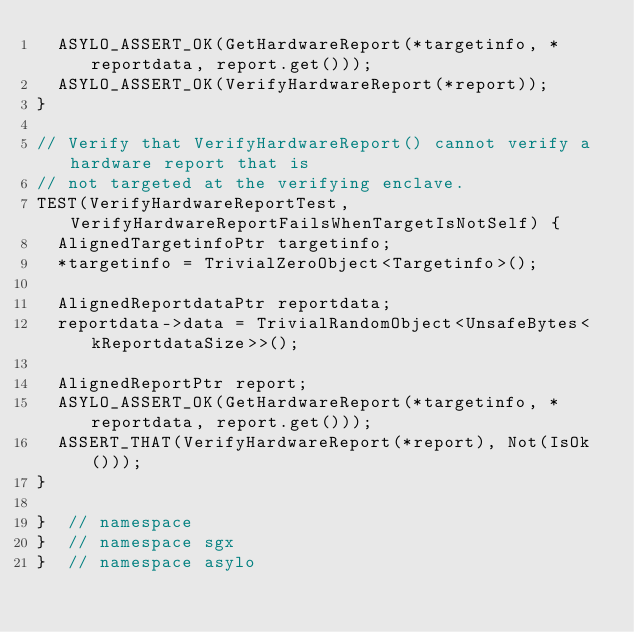Convert code to text. <code><loc_0><loc_0><loc_500><loc_500><_C++_>  ASYLO_ASSERT_OK(GetHardwareReport(*targetinfo, *reportdata, report.get()));
  ASYLO_ASSERT_OK(VerifyHardwareReport(*report));
}

// Verify that VerifyHardwareReport() cannot verify a hardware report that is
// not targeted at the verifying enclave.
TEST(VerifyHardwareReportTest, VerifyHardwareReportFailsWhenTargetIsNotSelf) {
  AlignedTargetinfoPtr targetinfo;
  *targetinfo = TrivialZeroObject<Targetinfo>();

  AlignedReportdataPtr reportdata;
  reportdata->data = TrivialRandomObject<UnsafeBytes<kReportdataSize>>();

  AlignedReportPtr report;
  ASYLO_ASSERT_OK(GetHardwareReport(*targetinfo, *reportdata, report.get()));
  ASSERT_THAT(VerifyHardwareReport(*report), Not(IsOk()));
}

}  // namespace
}  // namespace sgx
}  // namespace asylo
</code> 